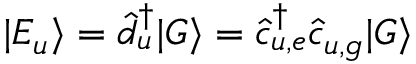Convert formula to latex. <formula><loc_0><loc_0><loc_500><loc_500>| E _ { u } \rangle = \hat { d } _ { u } ^ { \dagger } | G \rangle = \hat { c } _ { u , e } ^ { \dagger } \hat { c } _ { u , g } | G \rangle</formula> 